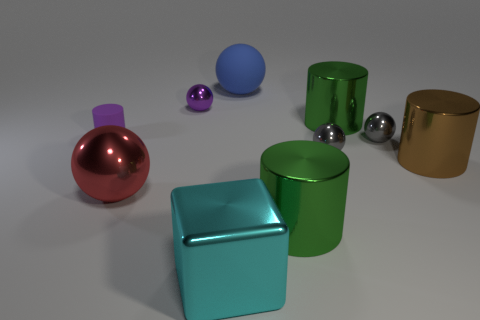There is a tiny sphere that is the same color as the small rubber cylinder; what material is it?
Make the answer very short. Metal. What number of small cyan blocks are there?
Offer a very short reply. 0. There is a rubber thing to the right of the purple rubber cylinder; does it have the same size as the brown metallic object?
Offer a very short reply. Yes. How many metal objects are tiny things or large cyan objects?
Offer a very short reply. 4. There is a brown shiny thing that is behind the red thing; how many blue balls are in front of it?
Your answer should be very brief. 0. There is a large shiny thing that is both behind the red ball and on the left side of the brown metallic cylinder; what shape is it?
Make the answer very short. Cylinder. There is a big green thing that is in front of the matte object in front of the tiny sphere left of the big blue object; what is its material?
Offer a very short reply. Metal. There is a thing that is the same color as the small matte cylinder; what is its size?
Your answer should be very brief. Small. What material is the big cyan thing?
Keep it short and to the point. Metal. Is the material of the blue sphere the same as the cylinder that is in front of the red thing?
Make the answer very short. No. 